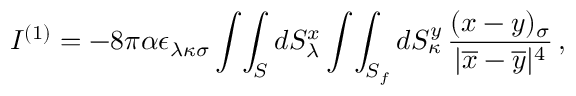Convert formula to latex. <formula><loc_0><loc_0><loc_500><loc_500>I ^ { ( 1 ) } = - 8 \pi \alpha \epsilon _ { \lambda \kappa \sigma } \int \, \int _ { S } d S _ { \lambda } ^ { x } \int \, \int _ { S _ { f } } d S _ { \kappa } ^ { y } \, \frac { ( x - y ) _ { \sigma } } { | \overline { x } - \overline { y } | ^ { 4 } } \, ,</formula> 